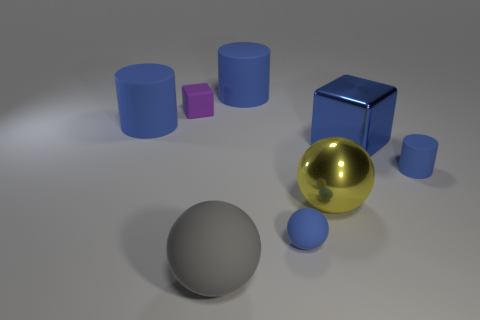Add 2 large blocks. How many objects exist? 10 Subtract all balls. How many objects are left? 5 Subtract all tiny blue balls. Subtract all small cylinders. How many objects are left? 6 Add 8 large blue cylinders. How many large blue cylinders are left? 10 Add 2 purple blocks. How many purple blocks exist? 3 Subtract 0 brown cylinders. How many objects are left? 8 